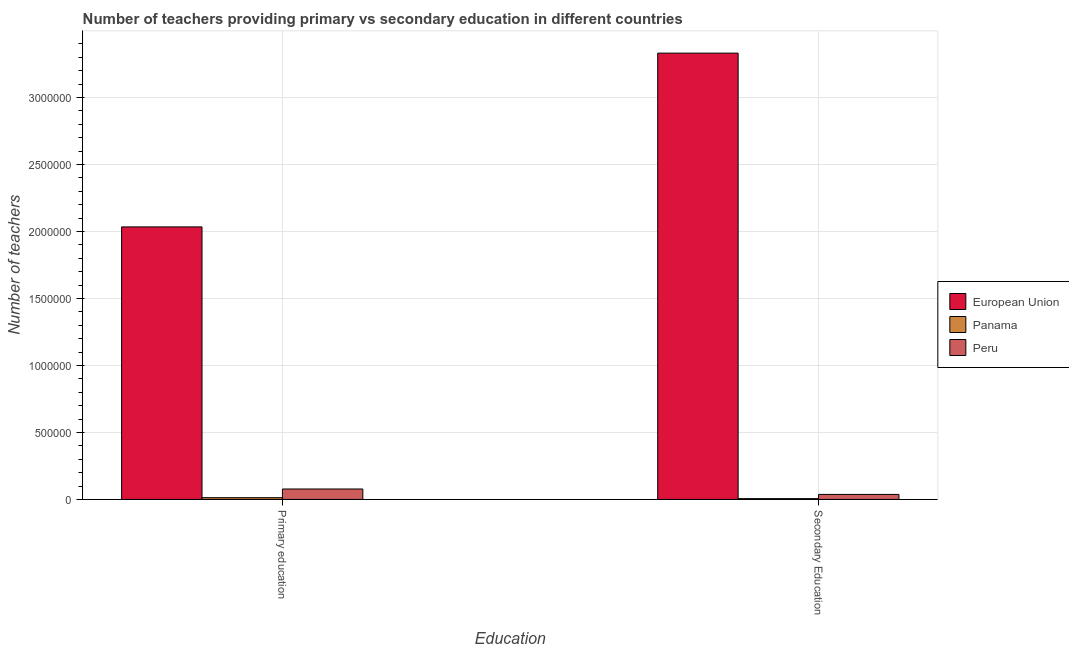How many groups of bars are there?
Your response must be concise. 2. Are the number of bars per tick equal to the number of legend labels?
Give a very brief answer. Yes. Are the number of bars on each tick of the X-axis equal?
Offer a terse response. Yes. What is the number of secondary teachers in Panama?
Your answer should be very brief. 5952. Across all countries, what is the maximum number of secondary teachers?
Your response must be concise. 3.33e+06. Across all countries, what is the minimum number of secondary teachers?
Keep it short and to the point. 5952. In which country was the number of primary teachers maximum?
Ensure brevity in your answer.  European Union. In which country was the number of secondary teachers minimum?
Your answer should be very brief. Panama. What is the total number of primary teachers in the graph?
Offer a very short reply. 2.13e+06. What is the difference between the number of secondary teachers in Panama and that in Peru?
Offer a very short reply. -3.14e+04. What is the difference between the number of primary teachers in European Union and the number of secondary teachers in Panama?
Give a very brief answer. 2.03e+06. What is the average number of primary teachers per country?
Your answer should be very brief. 7.08e+05. What is the difference between the number of primary teachers and number of secondary teachers in European Union?
Make the answer very short. -1.30e+06. What is the ratio of the number of secondary teachers in Panama to that in European Union?
Your answer should be very brief. 0. Is the number of primary teachers in European Union less than that in Peru?
Provide a short and direct response. No. What does the 3rd bar from the left in Secondary Education represents?
Your answer should be compact. Peru. What does the 3rd bar from the right in Secondary Education represents?
Your answer should be compact. European Union. Are all the bars in the graph horizontal?
Make the answer very short. No. Where does the legend appear in the graph?
Make the answer very short. Center right. How many legend labels are there?
Make the answer very short. 3. What is the title of the graph?
Keep it short and to the point. Number of teachers providing primary vs secondary education in different countries. What is the label or title of the X-axis?
Make the answer very short. Education. What is the label or title of the Y-axis?
Keep it short and to the point. Number of teachers. What is the Number of teachers of European Union in Primary education?
Offer a very short reply. 2.03e+06. What is the Number of teachers of Panama in Primary education?
Your answer should be very brief. 1.30e+04. What is the Number of teachers of Peru in Primary education?
Make the answer very short. 7.78e+04. What is the Number of teachers of European Union in Secondary Education?
Offer a terse response. 3.33e+06. What is the Number of teachers of Panama in Secondary Education?
Your answer should be compact. 5952. What is the Number of teachers in Peru in Secondary Education?
Provide a short and direct response. 3.74e+04. Across all Education, what is the maximum Number of teachers of European Union?
Provide a short and direct response. 3.33e+06. Across all Education, what is the maximum Number of teachers in Panama?
Make the answer very short. 1.30e+04. Across all Education, what is the maximum Number of teachers in Peru?
Your answer should be compact. 7.78e+04. Across all Education, what is the minimum Number of teachers in European Union?
Provide a succinct answer. 2.03e+06. Across all Education, what is the minimum Number of teachers of Panama?
Ensure brevity in your answer.  5952. Across all Education, what is the minimum Number of teachers of Peru?
Keep it short and to the point. 3.74e+04. What is the total Number of teachers of European Union in the graph?
Ensure brevity in your answer.  5.37e+06. What is the total Number of teachers of Panama in the graph?
Offer a very short reply. 1.90e+04. What is the total Number of teachers of Peru in the graph?
Your answer should be compact. 1.15e+05. What is the difference between the Number of teachers in European Union in Primary education and that in Secondary Education?
Your response must be concise. -1.30e+06. What is the difference between the Number of teachers in Panama in Primary education and that in Secondary Education?
Ensure brevity in your answer.  7080. What is the difference between the Number of teachers in Peru in Primary education and that in Secondary Education?
Provide a short and direct response. 4.05e+04. What is the difference between the Number of teachers in European Union in Primary education and the Number of teachers in Panama in Secondary Education?
Provide a succinct answer. 2.03e+06. What is the difference between the Number of teachers of European Union in Primary education and the Number of teachers of Peru in Secondary Education?
Keep it short and to the point. 2.00e+06. What is the difference between the Number of teachers of Panama in Primary education and the Number of teachers of Peru in Secondary Education?
Provide a succinct answer. -2.44e+04. What is the average Number of teachers of European Union per Education?
Offer a very short reply. 2.68e+06. What is the average Number of teachers in Panama per Education?
Give a very brief answer. 9492. What is the average Number of teachers in Peru per Education?
Your answer should be very brief. 5.76e+04. What is the difference between the Number of teachers in European Union and Number of teachers in Panama in Primary education?
Your answer should be compact. 2.02e+06. What is the difference between the Number of teachers in European Union and Number of teachers in Peru in Primary education?
Your answer should be compact. 1.96e+06. What is the difference between the Number of teachers in Panama and Number of teachers in Peru in Primary education?
Ensure brevity in your answer.  -6.48e+04. What is the difference between the Number of teachers in European Union and Number of teachers in Panama in Secondary Education?
Offer a terse response. 3.33e+06. What is the difference between the Number of teachers of European Union and Number of teachers of Peru in Secondary Education?
Offer a very short reply. 3.29e+06. What is the difference between the Number of teachers of Panama and Number of teachers of Peru in Secondary Education?
Offer a very short reply. -3.14e+04. What is the ratio of the Number of teachers in European Union in Primary education to that in Secondary Education?
Provide a succinct answer. 0.61. What is the ratio of the Number of teachers in Panama in Primary education to that in Secondary Education?
Offer a very short reply. 2.19. What is the ratio of the Number of teachers of Peru in Primary education to that in Secondary Education?
Your answer should be very brief. 2.08. What is the difference between the highest and the second highest Number of teachers of European Union?
Offer a very short reply. 1.30e+06. What is the difference between the highest and the second highest Number of teachers of Panama?
Keep it short and to the point. 7080. What is the difference between the highest and the second highest Number of teachers of Peru?
Ensure brevity in your answer.  4.05e+04. What is the difference between the highest and the lowest Number of teachers of European Union?
Keep it short and to the point. 1.30e+06. What is the difference between the highest and the lowest Number of teachers of Panama?
Give a very brief answer. 7080. What is the difference between the highest and the lowest Number of teachers of Peru?
Your answer should be very brief. 4.05e+04. 